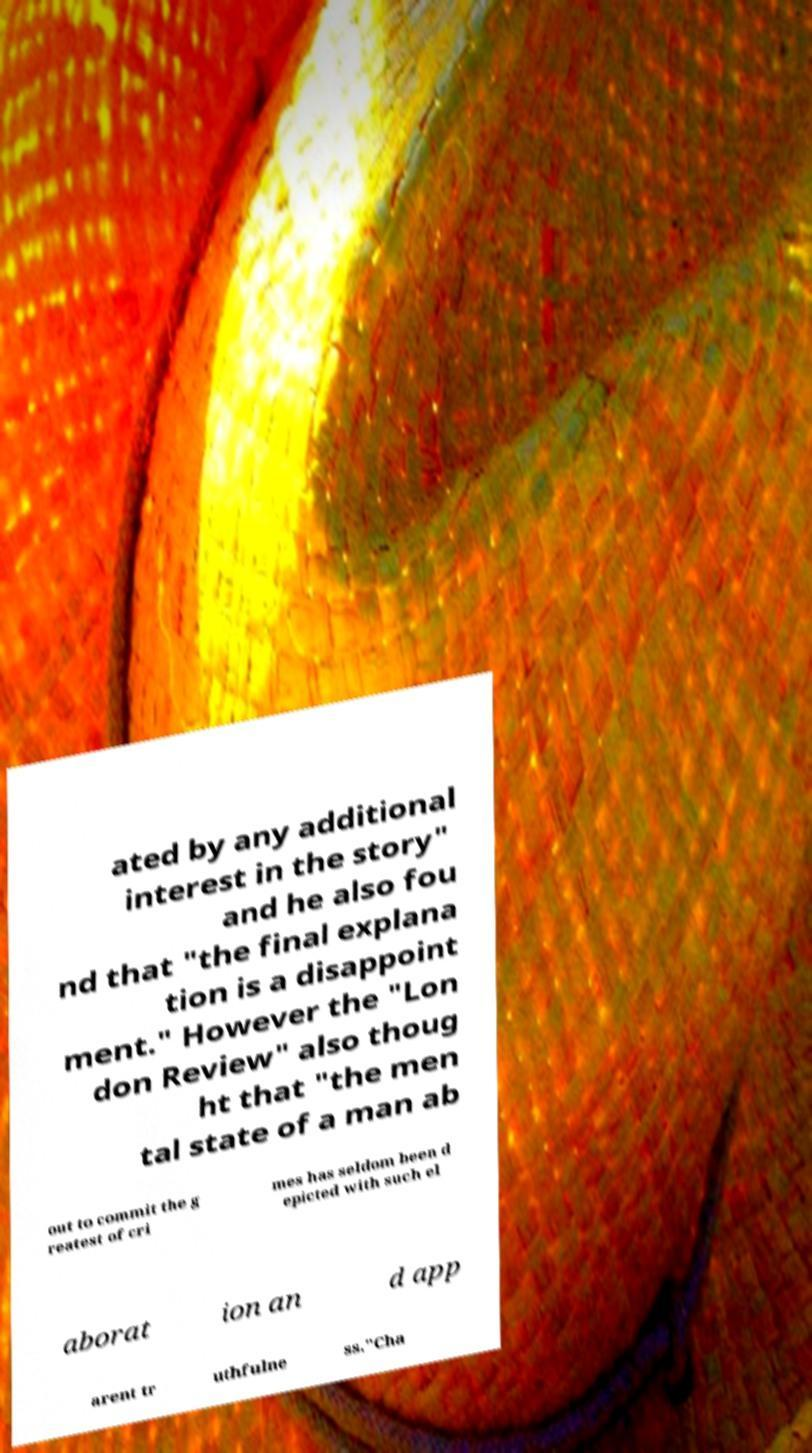Could you extract and type out the text from this image? ated by any additional interest in the story" and he also fou nd that "the final explana tion is a disappoint ment." However the "Lon don Review" also thoug ht that "the men tal state of a man ab out to commit the g reatest of cri mes has seldom been d epicted with such el aborat ion an d app arent tr uthfulne ss."Cha 